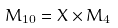Convert formula to latex. <formula><loc_0><loc_0><loc_500><loc_500>M _ { 1 0 } = X \times M _ { 4 }</formula> 